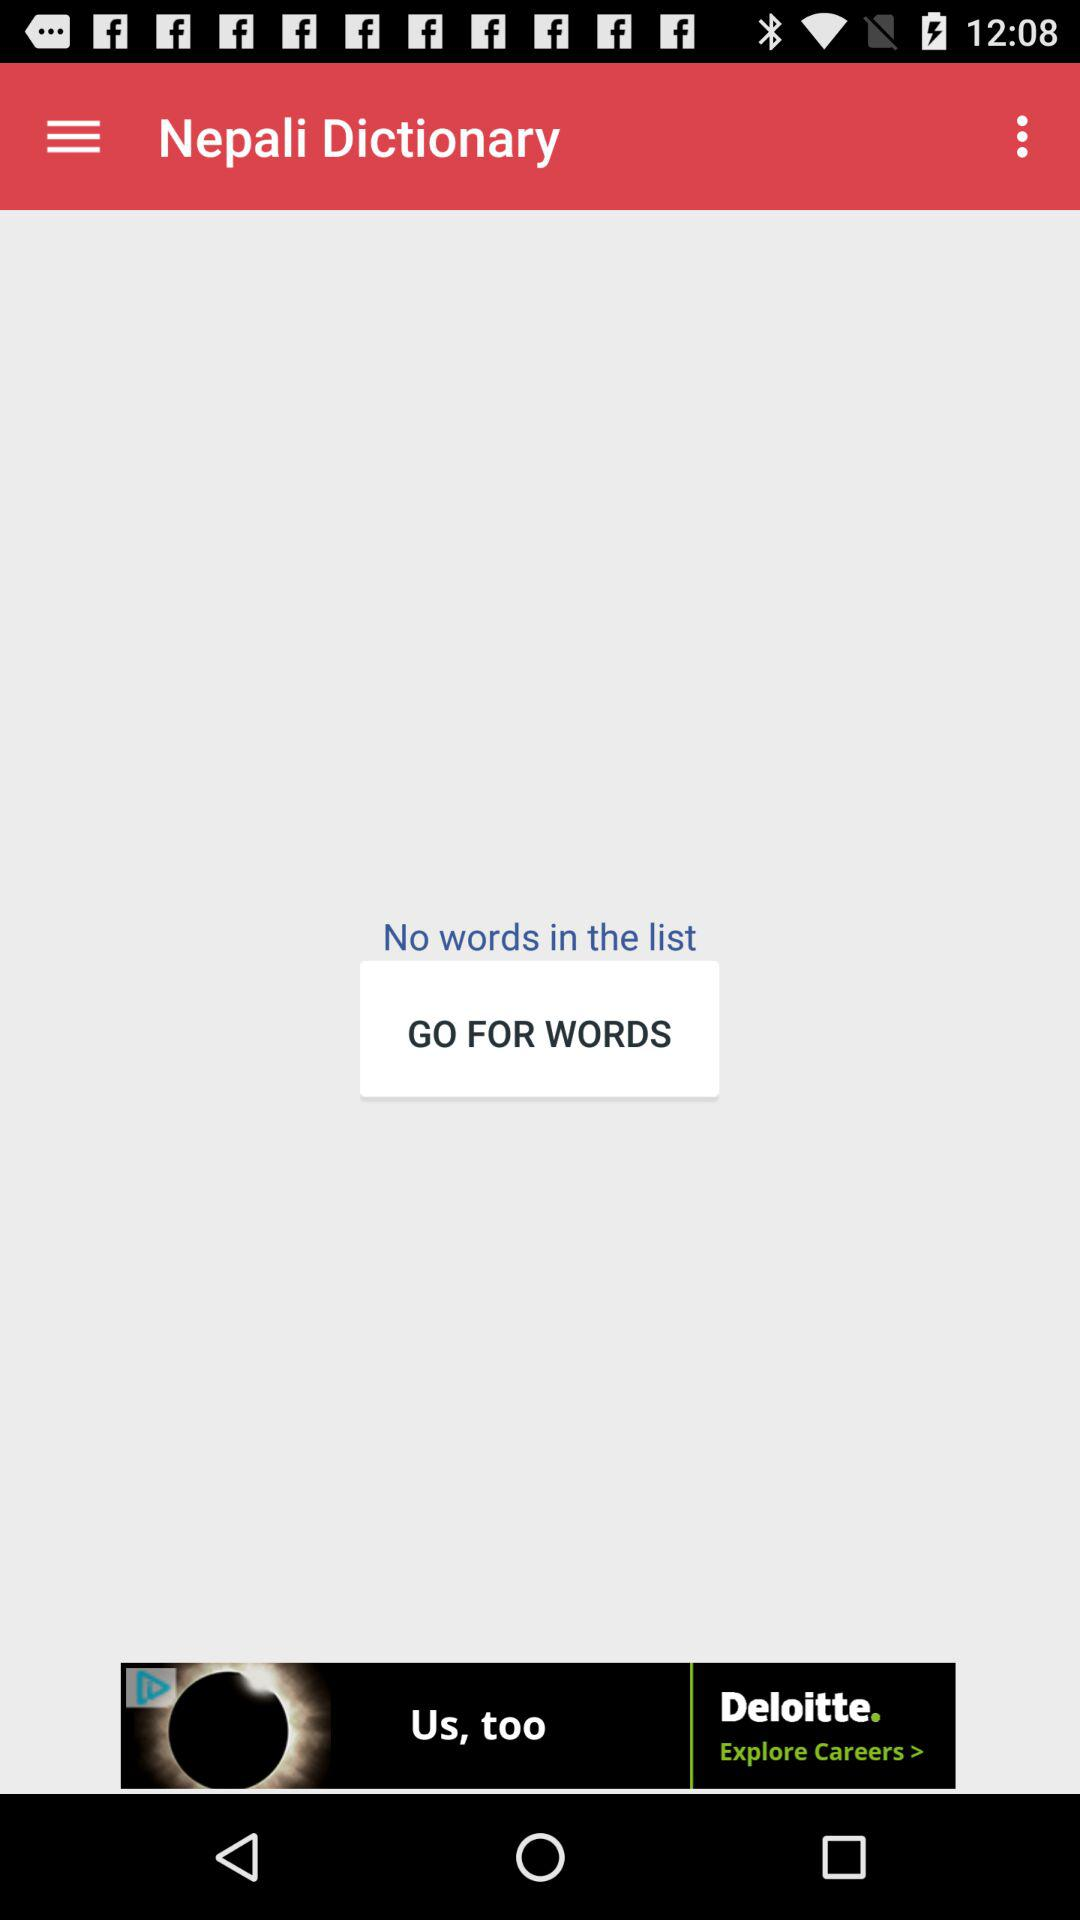Are there any words in the list? There are no words in the list. 